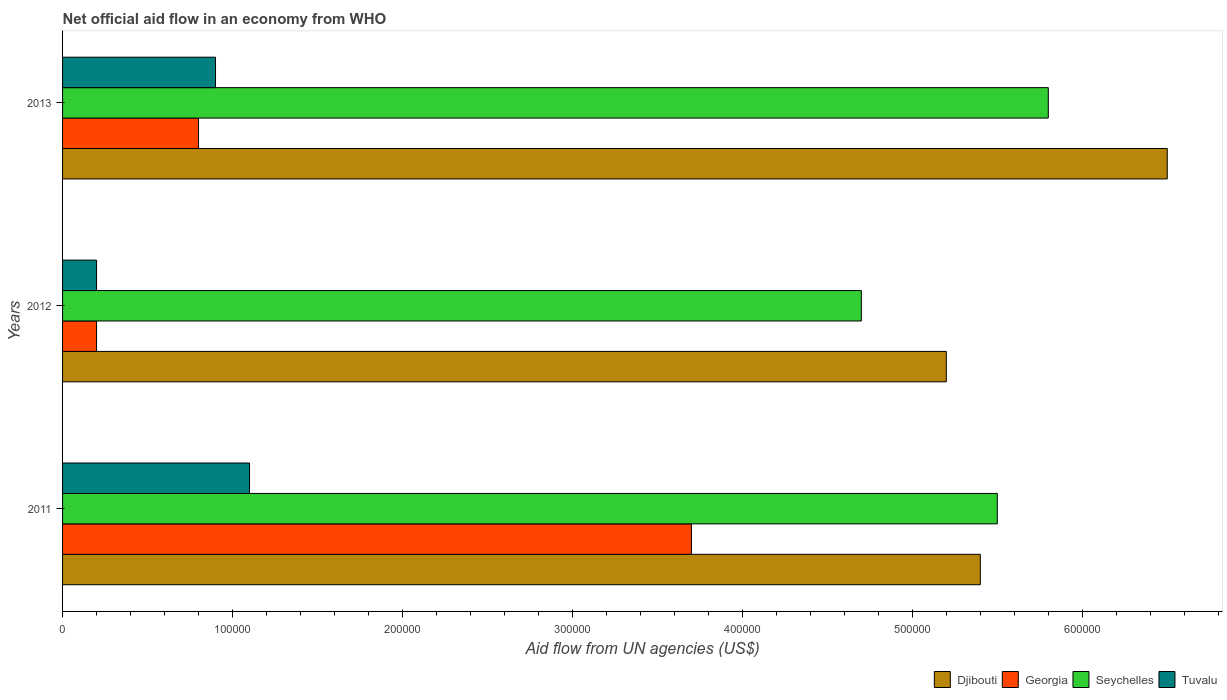How many groups of bars are there?
Offer a very short reply. 3. Are the number of bars per tick equal to the number of legend labels?
Your answer should be compact. Yes. Are the number of bars on each tick of the Y-axis equal?
Offer a very short reply. Yes. How many bars are there on the 1st tick from the top?
Provide a short and direct response. 4. How many bars are there on the 2nd tick from the bottom?
Make the answer very short. 4. What is the label of the 1st group of bars from the top?
Provide a succinct answer. 2013. In how many cases, is the number of bars for a given year not equal to the number of legend labels?
Your answer should be compact. 0. What is the net official aid flow in Tuvalu in 2012?
Give a very brief answer. 2.00e+04. Across all years, what is the maximum net official aid flow in Djibouti?
Offer a terse response. 6.50e+05. In which year was the net official aid flow in Tuvalu maximum?
Offer a very short reply. 2011. What is the difference between the net official aid flow in Seychelles in 2013 and the net official aid flow in Tuvalu in 2012?
Keep it short and to the point. 5.60e+05. What is the average net official aid flow in Tuvalu per year?
Offer a terse response. 7.33e+04. What is the ratio of the net official aid flow in Tuvalu in 2012 to that in 2013?
Offer a terse response. 0.22. Is the net official aid flow in Djibouti in 2011 less than that in 2013?
Your response must be concise. Yes. What is the difference between the highest and the lowest net official aid flow in Tuvalu?
Your answer should be very brief. 9.00e+04. In how many years, is the net official aid flow in Seychelles greater than the average net official aid flow in Seychelles taken over all years?
Offer a very short reply. 2. Is it the case that in every year, the sum of the net official aid flow in Tuvalu and net official aid flow in Seychelles is greater than the sum of net official aid flow in Georgia and net official aid flow in Djibouti?
Your answer should be very brief. Yes. What does the 1st bar from the top in 2013 represents?
Offer a terse response. Tuvalu. What does the 3rd bar from the bottom in 2012 represents?
Offer a terse response. Seychelles. Is it the case that in every year, the sum of the net official aid flow in Tuvalu and net official aid flow in Djibouti is greater than the net official aid flow in Georgia?
Your answer should be compact. Yes. How many years are there in the graph?
Your answer should be very brief. 3. Does the graph contain any zero values?
Offer a very short reply. No. How are the legend labels stacked?
Give a very brief answer. Horizontal. What is the title of the graph?
Provide a short and direct response. Net official aid flow in an economy from WHO. Does "Panama" appear as one of the legend labels in the graph?
Your answer should be compact. No. What is the label or title of the X-axis?
Offer a very short reply. Aid flow from UN agencies (US$). What is the label or title of the Y-axis?
Provide a succinct answer. Years. What is the Aid flow from UN agencies (US$) in Djibouti in 2011?
Provide a short and direct response. 5.40e+05. What is the Aid flow from UN agencies (US$) in Tuvalu in 2011?
Give a very brief answer. 1.10e+05. What is the Aid flow from UN agencies (US$) of Djibouti in 2012?
Your answer should be compact. 5.20e+05. What is the Aid flow from UN agencies (US$) in Georgia in 2012?
Keep it short and to the point. 2.00e+04. What is the Aid flow from UN agencies (US$) in Tuvalu in 2012?
Give a very brief answer. 2.00e+04. What is the Aid flow from UN agencies (US$) in Djibouti in 2013?
Offer a very short reply. 6.50e+05. What is the Aid flow from UN agencies (US$) of Georgia in 2013?
Your response must be concise. 8.00e+04. What is the Aid flow from UN agencies (US$) of Seychelles in 2013?
Make the answer very short. 5.80e+05. Across all years, what is the maximum Aid flow from UN agencies (US$) of Djibouti?
Keep it short and to the point. 6.50e+05. Across all years, what is the maximum Aid flow from UN agencies (US$) in Georgia?
Offer a terse response. 3.70e+05. Across all years, what is the maximum Aid flow from UN agencies (US$) in Seychelles?
Keep it short and to the point. 5.80e+05. Across all years, what is the maximum Aid flow from UN agencies (US$) in Tuvalu?
Make the answer very short. 1.10e+05. Across all years, what is the minimum Aid flow from UN agencies (US$) in Djibouti?
Your answer should be compact. 5.20e+05. Across all years, what is the minimum Aid flow from UN agencies (US$) of Seychelles?
Provide a short and direct response. 4.70e+05. Across all years, what is the minimum Aid flow from UN agencies (US$) of Tuvalu?
Your answer should be very brief. 2.00e+04. What is the total Aid flow from UN agencies (US$) in Djibouti in the graph?
Provide a succinct answer. 1.71e+06. What is the total Aid flow from UN agencies (US$) in Seychelles in the graph?
Your answer should be compact. 1.60e+06. What is the total Aid flow from UN agencies (US$) of Tuvalu in the graph?
Provide a short and direct response. 2.20e+05. What is the difference between the Aid flow from UN agencies (US$) in Djibouti in 2011 and that in 2012?
Offer a terse response. 2.00e+04. What is the difference between the Aid flow from UN agencies (US$) in Tuvalu in 2011 and that in 2012?
Provide a succinct answer. 9.00e+04. What is the difference between the Aid flow from UN agencies (US$) of Djibouti in 2012 and that in 2013?
Provide a succinct answer. -1.30e+05. What is the difference between the Aid flow from UN agencies (US$) of Georgia in 2012 and that in 2013?
Your response must be concise. -6.00e+04. What is the difference between the Aid flow from UN agencies (US$) of Seychelles in 2012 and that in 2013?
Keep it short and to the point. -1.10e+05. What is the difference between the Aid flow from UN agencies (US$) of Tuvalu in 2012 and that in 2013?
Your answer should be very brief. -7.00e+04. What is the difference between the Aid flow from UN agencies (US$) of Djibouti in 2011 and the Aid flow from UN agencies (US$) of Georgia in 2012?
Keep it short and to the point. 5.20e+05. What is the difference between the Aid flow from UN agencies (US$) in Djibouti in 2011 and the Aid flow from UN agencies (US$) in Seychelles in 2012?
Your response must be concise. 7.00e+04. What is the difference between the Aid flow from UN agencies (US$) of Djibouti in 2011 and the Aid flow from UN agencies (US$) of Tuvalu in 2012?
Make the answer very short. 5.20e+05. What is the difference between the Aid flow from UN agencies (US$) of Georgia in 2011 and the Aid flow from UN agencies (US$) of Seychelles in 2012?
Ensure brevity in your answer.  -1.00e+05. What is the difference between the Aid flow from UN agencies (US$) in Seychelles in 2011 and the Aid flow from UN agencies (US$) in Tuvalu in 2012?
Your response must be concise. 5.30e+05. What is the difference between the Aid flow from UN agencies (US$) in Djibouti in 2011 and the Aid flow from UN agencies (US$) in Georgia in 2013?
Make the answer very short. 4.60e+05. What is the difference between the Aid flow from UN agencies (US$) of Djibouti in 2011 and the Aid flow from UN agencies (US$) of Seychelles in 2013?
Your answer should be very brief. -4.00e+04. What is the difference between the Aid flow from UN agencies (US$) in Georgia in 2011 and the Aid flow from UN agencies (US$) in Seychelles in 2013?
Your answer should be compact. -2.10e+05. What is the difference between the Aid flow from UN agencies (US$) of Georgia in 2011 and the Aid flow from UN agencies (US$) of Tuvalu in 2013?
Your response must be concise. 2.80e+05. What is the difference between the Aid flow from UN agencies (US$) of Djibouti in 2012 and the Aid flow from UN agencies (US$) of Georgia in 2013?
Provide a succinct answer. 4.40e+05. What is the difference between the Aid flow from UN agencies (US$) of Djibouti in 2012 and the Aid flow from UN agencies (US$) of Tuvalu in 2013?
Keep it short and to the point. 4.30e+05. What is the difference between the Aid flow from UN agencies (US$) in Georgia in 2012 and the Aid flow from UN agencies (US$) in Seychelles in 2013?
Make the answer very short. -5.60e+05. What is the difference between the Aid flow from UN agencies (US$) in Seychelles in 2012 and the Aid flow from UN agencies (US$) in Tuvalu in 2013?
Provide a short and direct response. 3.80e+05. What is the average Aid flow from UN agencies (US$) of Djibouti per year?
Provide a short and direct response. 5.70e+05. What is the average Aid flow from UN agencies (US$) in Georgia per year?
Ensure brevity in your answer.  1.57e+05. What is the average Aid flow from UN agencies (US$) in Seychelles per year?
Your response must be concise. 5.33e+05. What is the average Aid flow from UN agencies (US$) in Tuvalu per year?
Make the answer very short. 7.33e+04. In the year 2011, what is the difference between the Aid flow from UN agencies (US$) in Djibouti and Aid flow from UN agencies (US$) in Tuvalu?
Offer a very short reply. 4.30e+05. In the year 2012, what is the difference between the Aid flow from UN agencies (US$) of Georgia and Aid flow from UN agencies (US$) of Seychelles?
Provide a succinct answer. -4.50e+05. In the year 2012, what is the difference between the Aid flow from UN agencies (US$) of Seychelles and Aid flow from UN agencies (US$) of Tuvalu?
Your answer should be very brief. 4.50e+05. In the year 2013, what is the difference between the Aid flow from UN agencies (US$) of Djibouti and Aid flow from UN agencies (US$) of Georgia?
Give a very brief answer. 5.70e+05. In the year 2013, what is the difference between the Aid flow from UN agencies (US$) in Djibouti and Aid flow from UN agencies (US$) in Tuvalu?
Your response must be concise. 5.60e+05. In the year 2013, what is the difference between the Aid flow from UN agencies (US$) in Georgia and Aid flow from UN agencies (US$) in Seychelles?
Provide a short and direct response. -5.00e+05. What is the ratio of the Aid flow from UN agencies (US$) in Seychelles in 2011 to that in 2012?
Give a very brief answer. 1.17. What is the ratio of the Aid flow from UN agencies (US$) of Djibouti in 2011 to that in 2013?
Provide a short and direct response. 0.83. What is the ratio of the Aid flow from UN agencies (US$) in Georgia in 2011 to that in 2013?
Your answer should be very brief. 4.62. What is the ratio of the Aid flow from UN agencies (US$) of Seychelles in 2011 to that in 2013?
Provide a short and direct response. 0.95. What is the ratio of the Aid flow from UN agencies (US$) in Tuvalu in 2011 to that in 2013?
Offer a terse response. 1.22. What is the ratio of the Aid flow from UN agencies (US$) in Georgia in 2012 to that in 2013?
Provide a succinct answer. 0.25. What is the ratio of the Aid flow from UN agencies (US$) of Seychelles in 2012 to that in 2013?
Make the answer very short. 0.81. What is the ratio of the Aid flow from UN agencies (US$) of Tuvalu in 2012 to that in 2013?
Offer a very short reply. 0.22. What is the difference between the highest and the second highest Aid flow from UN agencies (US$) of Tuvalu?
Provide a succinct answer. 2.00e+04. What is the difference between the highest and the lowest Aid flow from UN agencies (US$) of Tuvalu?
Provide a short and direct response. 9.00e+04. 